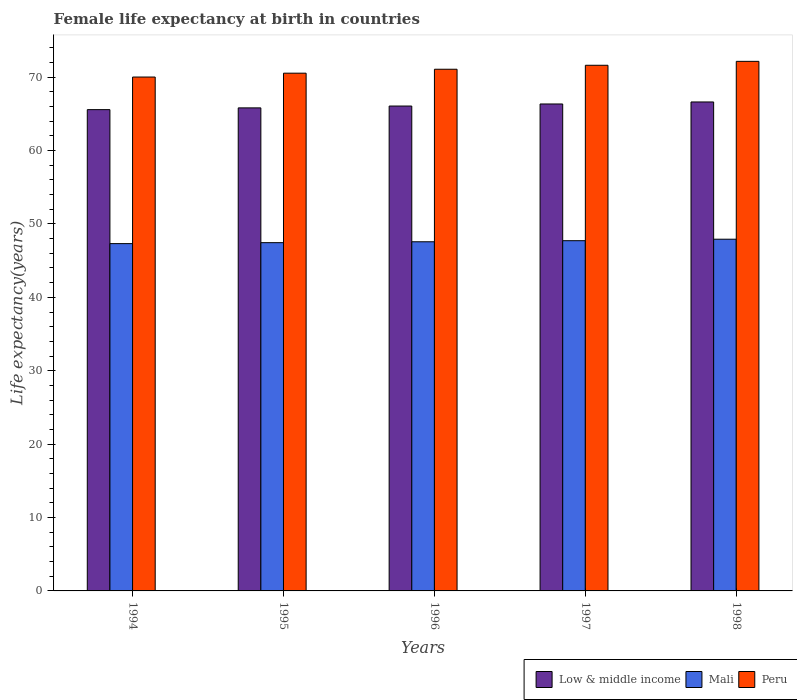How many different coloured bars are there?
Give a very brief answer. 3. How many groups of bars are there?
Your response must be concise. 5. Are the number of bars per tick equal to the number of legend labels?
Offer a terse response. Yes. How many bars are there on the 3rd tick from the left?
Your answer should be very brief. 3. How many bars are there on the 4th tick from the right?
Give a very brief answer. 3. What is the label of the 1st group of bars from the left?
Offer a very short reply. 1994. In how many cases, is the number of bars for a given year not equal to the number of legend labels?
Provide a succinct answer. 0. What is the female life expectancy at birth in Mali in 1997?
Provide a short and direct response. 47.72. Across all years, what is the maximum female life expectancy at birth in Low & middle income?
Offer a terse response. 66.62. Across all years, what is the minimum female life expectancy at birth in Low & middle income?
Provide a succinct answer. 65.57. In which year was the female life expectancy at birth in Peru maximum?
Provide a short and direct response. 1998. What is the total female life expectancy at birth in Mali in the graph?
Your response must be concise. 237.97. What is the difference between the female life expectancy at birth in Low & middle income in 1996 and that in 1998?
Your response must be concise. -0.56. What is the difference between the female life expectancy at birth in Low & middle income in 1997 and the female life expectancy at birth in Peru in 1994?
Your answer should be very brief. -3.67. What is the average female life expectancy at birth in Mali per year?
Give a very brief answer. 47.59. In the year 1994, what is the difference between the female life expectancy at birth in Low & middle income and female life expectancy at birth in Peru?
Your answer should be very brief. -4.44. What is the ratio of the female life expectancy at birth in Low & middle income in 1996 to that in 1997?
Ensure brevity in your answer.  1. Is the difference between the female life expectancy at birth in Low & middle income in 1995 and 1998 greater than the difference between the female life expectancy at birth in Peru in 1995 and 1998?
Your response must be concise. Yes. What is the difference between the highest and the second highest female life expectancy at birth in Low & middle income?
Make the answer very short. 0.27. What is the difference between the highest and the lowest female life expectancy at birth in Low & middle income?
Make the answer very short. 1.05. In how many years, is the female life expectancy at birth in Peru greater than the average female life expectancy at birth in Peru taken over all years?
Ensure brevity in your answer.  2. What does the 1st bar from the left in 1996 represents?
Offer a very short reply. Low & middle income. What does the 3rd bar from the right in 1995 represents?
Your response must be concise. Low & middle income. Are all the bars in the graph horizontal?
Your response must be concise. No. How many years are there in the graph?
Make the answer very short. 5. Does the graph contain grids?
Provide a succinct answer. No. How many legend labels are there?
Your response must be concise. 3. How are the legend labels stacked?
Provide a short and direct response. Horizontal. What is the title of the graph?
Your answer should be compact. Female life expectancy at birth in countries. Does "United Kingdom" appear as one of the legend labels in the graph?
Keep it short and to the point. No. What is the label or title of the X-axis?
Your response must be concise. Years. What is the label or title of the Y-axis?
Offer a terse response. Life expectancy(years). What is the Life expectancy(years) in Low & middle income in 1994?
Your answer should be compact. 65.57. What is the Life expectancy(years) of Mali in 1994?
Your answer should be very brief. 47.32. What is the Life expectancy(years) in Peru in 1994?
Make the answer very short. 70.01. What is the Life expectancy(years) in Low & middle income in 1995?
Your response must be concise. 65.81. What is the Life expectancy(years) in Mali in 1995?
Provide a succinct answer. 47.45. What is the Life expectancy(years) of Peru in 1995?
Provide a succinct answer. 70.54. What is the Life expectancy(years) of Low & middle income in 1996?
Your answer should be compact. 66.06. What is the Life expectancy(years) of Mali in 1996?
Your answer should be very brief. 47.57. What is the Life expectancy(years) in Peru in 1996?
Your response must be concise. 71.08. What is the Life expectancy(years) in Low & middle income in 1997?
Provide a succinct answer. 66.34. What is the Life expectancy(years) of Mali in 1997?
Provide a short and direct response. 47.72. What is the Life expectancy(years) in Peru in 1997?
Your answer should be compact. 71.61. What is the Life expectancy(years) of Low & middle income in 1998?
Your answer should be compact. 66.62. What is the Life expectancy(years) in Mali in 1998?
Give a very brief answer. 47.92. What is the Life expectancy(years) in Peru in 1998?
Give a very brief answer. 72.15. Across all years, what is the maximum Life expectancy(years) of Low & middle income?
Ensure brevity in your answer.  66.62. Across all years, what is the maximum Life expectancy(years) of Mali?
Your response must be concise. 47.92. Across all years, what is the maximum Life expectancy(years) in Peru?
Your answer should be compact. 72.15. Across all years, what is the minimum Life expectancy(years) in Low & middle income?
Offer a very short reply. 65.57. Across all years, what is the minimum Life expectancy(years) in Mali?
Give a very brief answer. 47.32. Across all years, what is the minimum Life expectancy(years) in Peru?
Keep it short and to the point. 70.01. What is the total Life expectancy(years) in Low & middle income in the graph?
Keep it short and to the point. 330.4. What is the total Life expectancy(years) of Mali in the graph?
Your answer should be compact. 237.97. What is the total Life expectancy(years) of Peru in the graph?
Your answer should be very brief. 355.39. What is the difference between the Life expectancy(years) of Low & middle income in 1994 and that in 1995?
Make the answer very short. -0.24. What is the difference between the Life expectancy(years) of Mali in 1994 and that in 1995?
Offer a very short reply. -0.13. What is the difference between the Life expectancy(years) of Peru in 1994 and that in 1995?
Ensure brevity in your answer.  -0.53. What is the difference between the Life expectancy(years) in Low & middle income in 1994 and that in 1996?
Your response must be concise. -0.49. What is the difference between the Life expectancy(years) in Peru in 1994 and that in 1996?
Your answer should be compact. -1.06. What is the difference between the Life expectancy(years) in Low & middle income in 1994 and that in 1997?
Your answer should be compact. -0.77. What is the difference between the Life expectancy(years) in Mali in 1994 and that in 1997?
Give a very brief answer. -0.4. What is the difference between the Life expectancy(years) of Peru in 1994 and that in 1997?
Provide a succinct answer. -1.6. What is the difference between the Life expectancy(years) of Low & middle income in 1994 and that in 1998?
Keep it short and to the point. -1.05. What is the difference between the Life expectancy(years) of Mali in 1994 and that in 1998?
Offer a very short reply. -0.6. What is the difference between the Life expectancy(years) of Peru in 1994 and that in 1998?
Keep it short and to the point. -2.14. What is the difference between the Life expectancy(years) of Low & middle income in 1995 and that in 1996?
Offer a very short reply. -0.25. What is the difference between the Life expectancy(years) of Mali in 1995 and that in 1996?
Your response must be concise. -0.12. What is the difference between the Life expectancy(years) in Peru in 1995 and that in 1996?
Offer a very short reply. -0.54. What is the difference between the Life expectancy(years) of Low & middle income in 1995 and that in 1997?
Your response must be concise. -0.53. What is the difference between the Life expectancy(years) in Mali in 1995 and that in 1997?
Your answer should be compact. -0.27. What is the difference between the Life expectancy(years) of Peru in 1995 and that in 1997?
Your response must be concise. -1.08. What is the difference between the Life expectancy(years) of Low & middle income in 1995 and that in 1998?
Provide a short and direct response. -0.81. What is the difference between the Life expectancy(years) in Mali in 1995 and that in 1998?
Make the answer very short. -0.47. What is the difference between the Life expectancy(years) in Peru in 1995 and that in 1998?
Your response must be concise. -1.61. What is the difference between the Life expectancy(years) of Low & middle income in 1996 and that in 1997?
Give a very brief answer. -0.28. What is the difference between the Life expectancy(years) of Mali in 1996 and that in 1997?
Offer a terse response. -0.15. What is the difference between the Life expectancy(years) of Peru in 1996 and that in 1997?
Provide a succinct answer. -0.54. What is the difference between the Life expectancy(years) of Low & middle income in 1996 and that in 1998?
Your answer should be very brief. -0.56. What is the difference between the Life expectancy(years) of Mali in 1996 and that in 1998?
Ensure brevity in your answer.  -0.35. What is the difference between the Life expectancy(years) of Peru in 1996 and that in 1998?
Offer a very short reply. -1.07. What is the difference between the Life expectancy(years) in Low & middle income in 1997 and that in 1998?
Your answer should be very brief. -0.27. What is the difference between the Life expectancy(years) in Mali in 1997 and that in 1998?
Provide a short and direct response. -0.2. What is the difference between the Life expectancy(years) in Peru in 1997 and that in 1998?
Offer a very short reply. -0.54. What is the difference between the Life expectancy(years) of Low & middle income in 1994 and the Life expectancy(years) of Mali in 1995?
Your answer should be compact. 18.12. What is the difference between the Life expectancy(years) of Low & middle income in 1994 and the Life expectancy(years) of Peru in 1995?
Your answer should be very brief. -4.97. What is the difference between the Life expectancy(years) of Mali in 1994 and the Life expectancy(years) of Peru in 1995?
Offer a very short reply. -23.22. What is the difference between the Life expectancy(years) in Low & middle income in 1994 and the Life expectancy(years) in Mali in 1996?
Keep it short and to the point. 18. What is the difference between the Life expectancy(years) in Low & middle income in 1994 and the Life expectancy(years) in Peru in 1996?
Keep it short and to the point. -5.5. What is the difference between the Life expectancy(years) of Mali in 1994 and the Life expectancy(years) of Peru in 1996?
Your response must be concise. -23.76. What is the difference between the Life expectancy(years) in Low & middle income in 1994 and the Life expectancy(years) in Mali in 1997?
Your response must be concise. 17.85. What is the difference between the Life expectancy(years) of Low & middle income in 1994 and the Life expectancy(years) of Peru in 1997?
Offer a very short reply. -6.04. What is the difference between the Life expectancy(years) of Mali in 1994 and the Life expectancy(years) of Peru in 1997?
Ensure brevity in your answer.  -24.3. What is the difference between the Life expectancy(years) of Low & middle income in 1994 and the Life expectancy(years) of Mali in 1998?
Give a very brief answer. 17.65. What is the difference between the Life expectancy(years) in Low & middle income in 1994 and the Life expectancy(years) in Peru in 1998?
Offer a very short reply. -6.58. What is the difference between the Life expectancy(years) in Mali in 1994 and the Life expectancy(years) in Peru in 1998?
Your answer should be very brief. -24.83. What is the difference between the Life expectancy(years) in Low & middle income in 1995 and the Life expectancy(years) in Mali in 1996?
Ensure brevity in your answer.  18.24. What is the difference between the Life expectancy(years) in Low & middle income in 1995 and the Life expectancy(years) in Peru in 1996?
Provide a succinct answer. -5.26. What is the difference between the Life expectancy(years) of Mali in 1995 and the Life expectancy(years) of Peru in 1996?
Your response must be concise. -23.63. What is the difference between the Life expectancy(years) of Low & middle income in 1995 and the Life expectancy(years) of Mali in 1997?
Make the answer very short. 18.09. What is the difference between the Life expectancy(years) in Low & middle income in 1995 and the Life expectancy(years) in Peru in 1997?
Keep it short and to the point. -5.8. What is the difference between the Life expectancy(years) in Mali in 1995 and the Life expectancy(years) in Peru in 1997?
Make the answer very short. -24.17. What is the difference between the Life expectancy(years) of Low & middle income in 1995 and the Life expectancy(years) of Mali in 1998?
Make the answer very short. 17.89. What is the difference between the Life expectancy(years) of Low & middle income in 1995 and the Life expectancy(years) of Peru in 1998?
Your answer should be compact. -6.34. What is the difference between the Life expectancy(years) in Mali in 1995 and the Life expectancy(years) in Peru in 1998?
Offer a very short reply. -24.7. What is the difference between the Life expectancy(years) of Low & middle income in 1996 and the Life expectancy(years) of Mali in 1997?
Your response must be concise. 18.34. What is the difference between the Life expectancy(years) in Low & middle income in 1996 and the Life expectancy(years) in Peru in 1997?
Your answer should be compact. -5.55. What is the difference between the Life expectancy(years) in Mali in 1996 and the Life expectancy(years) in Peru in 1997?
Your answer should be very brief. -24.05. What is the difference between the Life expectancy(years) of Low & middle income in 1996 and the Life expectancy(years) of Mali in 1998?
Your answer should be very brief. 18.14. What is the difference between the Life expectancy(years) of Low & middle income in 1996 and the Life expectancy(years) of Peru in 1998?
Provide a short and direct response. -6.09. What is the difference between the Life expectancy(years) of Mali in 1996 and the Life expectancy(years) of Peru in 1998?
Ensure brevity in your answer.  -24.58. What is the difference between the Life expectancy(years) in Low & middle income in 1997 and the Life expectancy(years) in Mali in 1998?
Offer a terse response. 18.42. What is the difference between the Life expectancy(years) of Low & middle income in 1997 and the Life expectancy(years) of Peru in 1998?
Your answer should be very brief. -5.81. What is the difference between the Life expectancy(years) in Mali in 1997 and the Life expectancy(years) in Peru in 1998?
Offer a terse response. -24.43. What is the average Life expectancy(years) of Low & middle income per year?
Provide a succinct answer. 66.08. What is the average Life expectancy(years) of Mali per year?
Your response must be concise. 47.59. What is the average Life expectancy(years) of Peru per year?
Keep it short and to the point. 71.08. In the year 1994, what is the difference between the Life expectancy(years) of Low & middle income and Life expectancy(years) of Mali?
Your response must be concise. 18.25. In the year 1994, what is the difference between the Life expectancy(years) of Low & middle income and Life expectancy(years) of Peru?
Ensure brevity in your answer.  -4.44. In the year 1994, what is the difference between the Life expectancy(years) in Mali and Life expectancy(years) in Peru?
Give a very brief answer. -22.69. In the year 1995, what is the difference between the Life expectancy(years) of Low & middle income and Life expectancy(years) of Mali?
Provide a succinct answer. 18.36. In the year 1995, what is the difference between the Life expectancy(years) of Low & middle income and Life expectancy(years) of Peru?
Provide a short and direct response. -4.73. In the year 1995, what is the difference between the Life expectancy(years) of Mali and Life expectancy(years) of Peru?
Your answer should be very brief. -23.09. In the year 1996, what is the difference between the Life expectancy(years) of Low & middle income and Life expectancy(years) of Mali?
Keep it short and to the point. 18.49. In the year 1996, what is the difference between the Life expectancy(years) of Low & middle income and Life expectancy(years) of Peru?
Offer a terse response. -5.01. In the year 1996, what is the difference between the Life expectancy(years) in Mali and Life expectancy(years) in Peru?
Offer a very short reply. -23.51. In the year 1997, what is the difference between the Life expectancy(years) in Low & middle income and Life expectancy(years) in Mali?
Your response must be concise. 18.63. In the year 1997, what is the difference between the Life expectancy(years) in Low & middle income and Life expectancy(years) in Peru?
Provide a succinct answer. -5.27. In the year 1997, what is the difference between the Life expectancy(years) in Mali and Life expectancy(years) in Peru?
Your answer should be very brief. -23.9. In the year 1998, what is the difference between the Life expectancy(years) in Low & middle income and Life expectancy(years) in Mali?
Offer a very short reply. 18.7. In the year 1998, what is the difference between the Life expectancy(years) of Low & middle income and Life expectancy(years) of Peru?
Your response must be concise. -5.53. In the year 1998, what is the difference between the Life expectancy(years) in Mali and Life expectancy(years) in Peru?
Ensure brevity in your answer.  -24.23. What is the ratio of the Life expectancy(years) of Mali in 1994 to that in 1995?
Your answer should be compact. 1. What is the ratio of the Life expectancy(years) of Peru in 1994 to that in 1995?
Your response must be concise. 0.99. What is the ratio of the Life expectancy(years) in Low & middle income in 1994 to that in 1996?
Make the answer very short. 0.99. What is the ratio of the Life expectancy(years) of Mali in 1994 to that in 1996?
Give a very brief answer. 0.99. What is the ratio of the Life expectancy(years) of Low & middle income in 1994 to that in 1997?
Offer a very short reply. 0.99. What is the ratio of the Life expectancy(years) in Peru in 1994 to that in 1997?
Offer a terse response. 0.98. What is the ratio of the Life expectancy(years) of Low & middle income in 1994 to that in 1998?
Your response must be concise. 0.98. What is the ratio of the Life expectancy(years) of Mali in 1994 to that in 1998?
Provide a short and direct response. 0.99. What is the ratio of the Life expectancy(years) of Peru in 1994 to that in 1998?
Ensure brevity in your answer.  0.97. What is the ratio of the Life expectancy(years) in Peru in 1995 to that in 1996?
Keep it short and to the point. 0.99. What is the ratio of the Life expectancy(years) in Low & middle income in 1995 to that in 1997?
Your answer should be compact. 0.99. What is the ratio of the Life expectancy(years) in Mali in 1995 to that in 1997?
Offer a very short reply. 0.99. What is the ratio of the Life expectancy(years) in Peru in 1995 to that in 1997?
Provide a short and direct response. 0.98. What is the ratio of the Life expectancy(years) in Low & middle income in 1995 to that in 1998?
Your response must be concise. 0.99. What is the ratio of the Life expectancy(years) of Mali in 1995 to that in 1998?
Offer a terse response. 0.99. What is the ratio of the Life expectancy(years) of Peru in 1995 to that in 1998?
Make the answer very short. 0.98. What is the ratio of the Life expectancy(years) of Peru in 1996 to that in 1997?
Give a very brief answer. 0.99. What is the ratio of the Life expectancy(years) of Peru in 1996 to that in 1998?
Your answer should be very brief. 0.99. What is the ratio of the Life expectancy(years) of Low & middle income in 1997 to that in 1998?
Offer a terse response. 1. What is the ratio of the Life expectancy(years) in Mali in 1997 to that in 1998?
Provide a succinct answer. 1. What is the ratio of the Life expectancy(years) of Peru in 1997 to that in 1998?
Your answer should be compact. 0.99. What is the difference between the highest and the second highest Life expectancy(years) of Low & middle income?
Your response must be concise. 0.27. What is the difference between the highest and the second highest Life expectancy(years) of Mali?
Keep it short and to the point. 0.2. What is the difference between the highest and the second highest Life expectancy(years) of Peru?
Make the answer very short. 0.54. What is the difference between the highest and the lowest Life expectancy(years) of Low & middle income?
Ensure brevity in your answer.  1.05. What is the difference between the highest and the lowest Life expectancy(years) in Mali?
Offer a very short reply. 0.6. What is the difference between the highest and the lowest Life expectancy(years) of Peru?
Give a very brief answer. 2.14. 